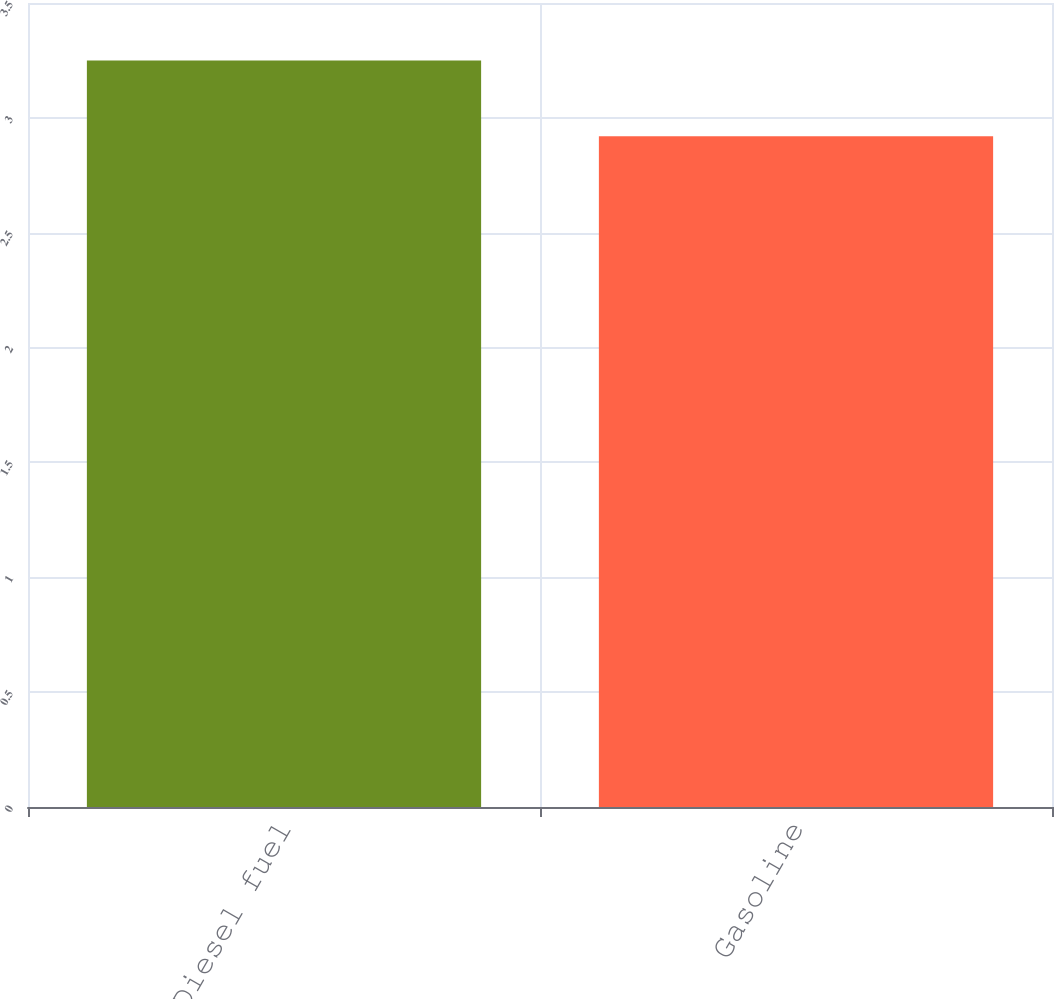Convert chart. <chart><loc_0><loc_0><loc_500><loc_500><bar_chart><fcel>Diesel fuel<fcel>Gasoline<nl><fcel>3.25<fcel>2.92<nl></chart> 